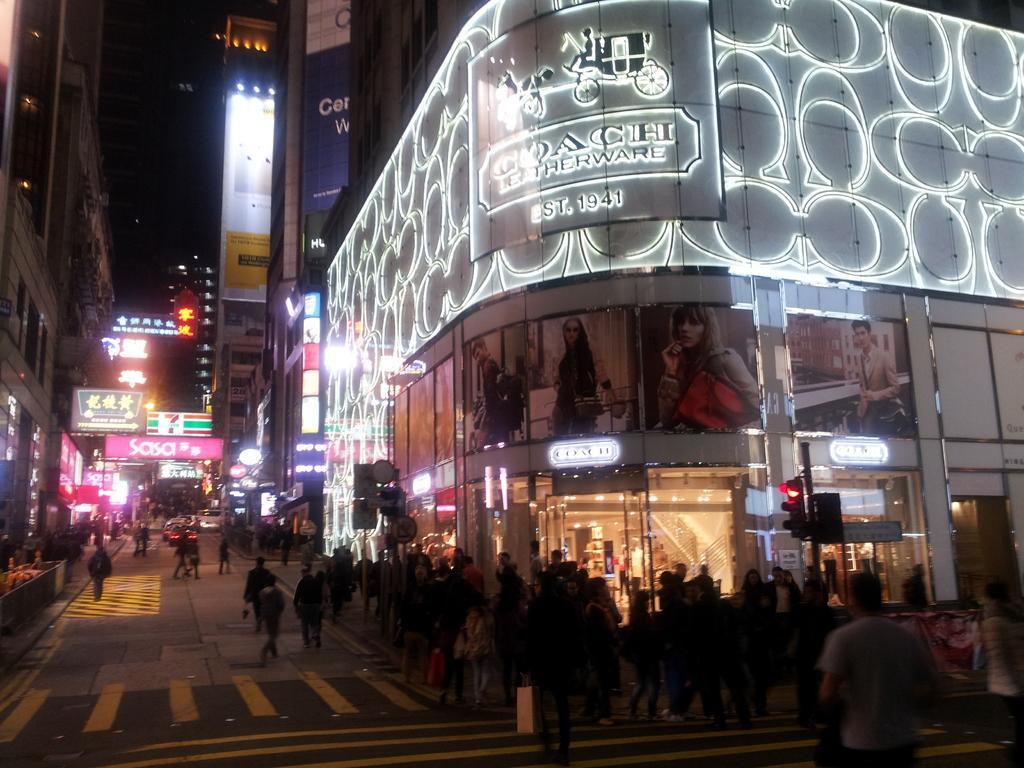Could you give a brief overview of what you see in this image? This image is taken outdoors. At the bottom of the image there is a road. In the middle of the image many people are walking on the road and a few vehicles are moving on the road. In this image there are a few buildings. There are many boards with text on them. There are many lights and there are a few signal lights, sign boards and poles. 